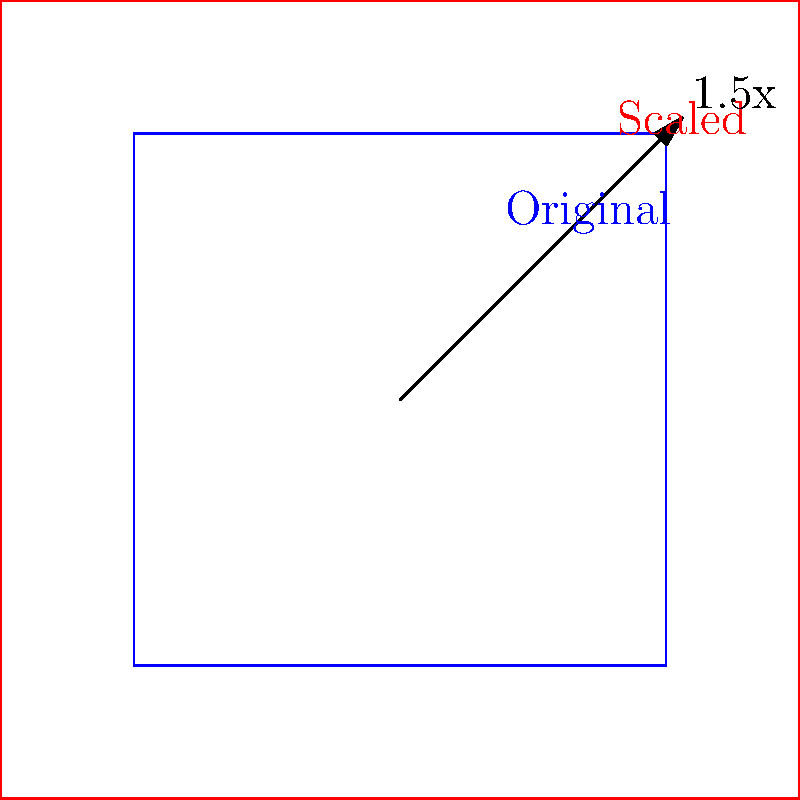A lighting rig setup needs to be scaled up to fit a larger studio space. If the original rig has dimensions of 8m x 8m and needs to be scaled by a factor of 1.5, what will be the dimensions of the new lighting rig setup? To solve this problem, we'll use the concept of scaling in transformational geometry. Here's a step-by-step explanation:

1. Identify the original dimensions:
   Original width = 8m
   Original height = 8m

2. Understand the scaling factor:
   The rig needs to be scaled by a factor of 1.5

3. Apply the scaling factor to both dimensions:
   New width = Original width × Scaling factor
   New width = 8m × 1.5 = 12m

   New height = Original height × Scaling factor
   New height = 8m × 1.5 = 12m

4. Express the new dimensions:
   The new lighting rig setup will have dimensions of 12m x 12m

Note: In transformational geometry, when we scale a shape, all of its dimensions are multiplied by the scaling factor. This preserves the shape's proportions while changing its size.
Answer: 12m x 12m 